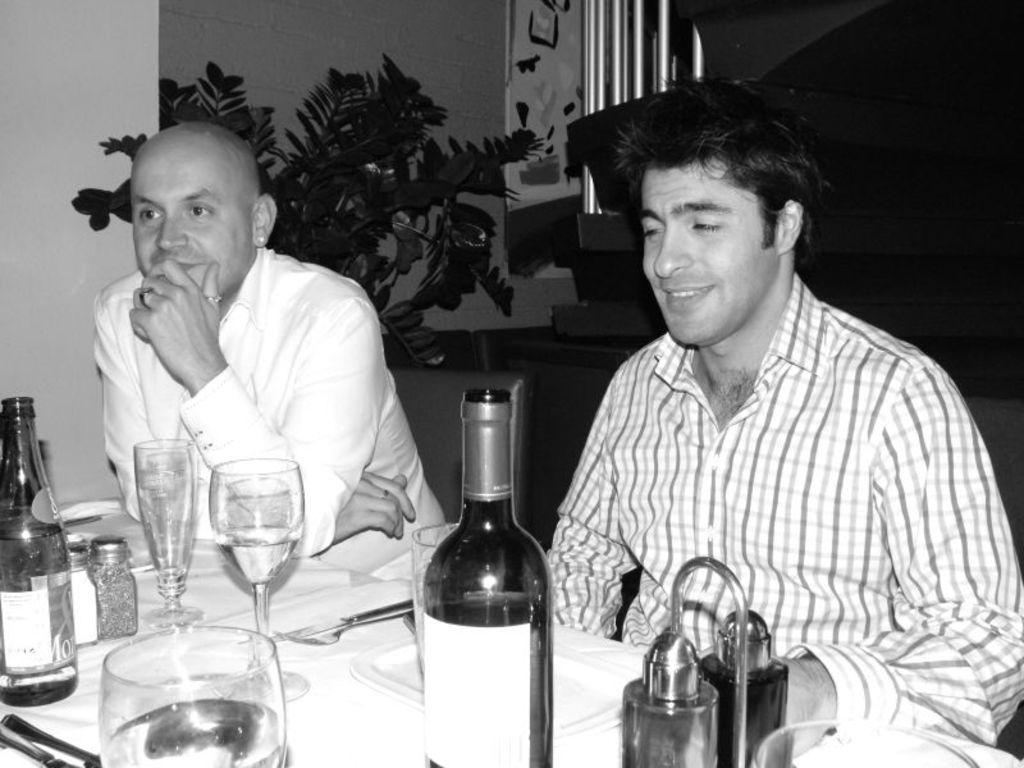Please provide a concise description of this image. In this image I see 2 men who are sitting and there is a table in front of them on which there are glasses, bottles, spoons and other things. I can also see this man is smiling. In the background I see the plant and the wall. 